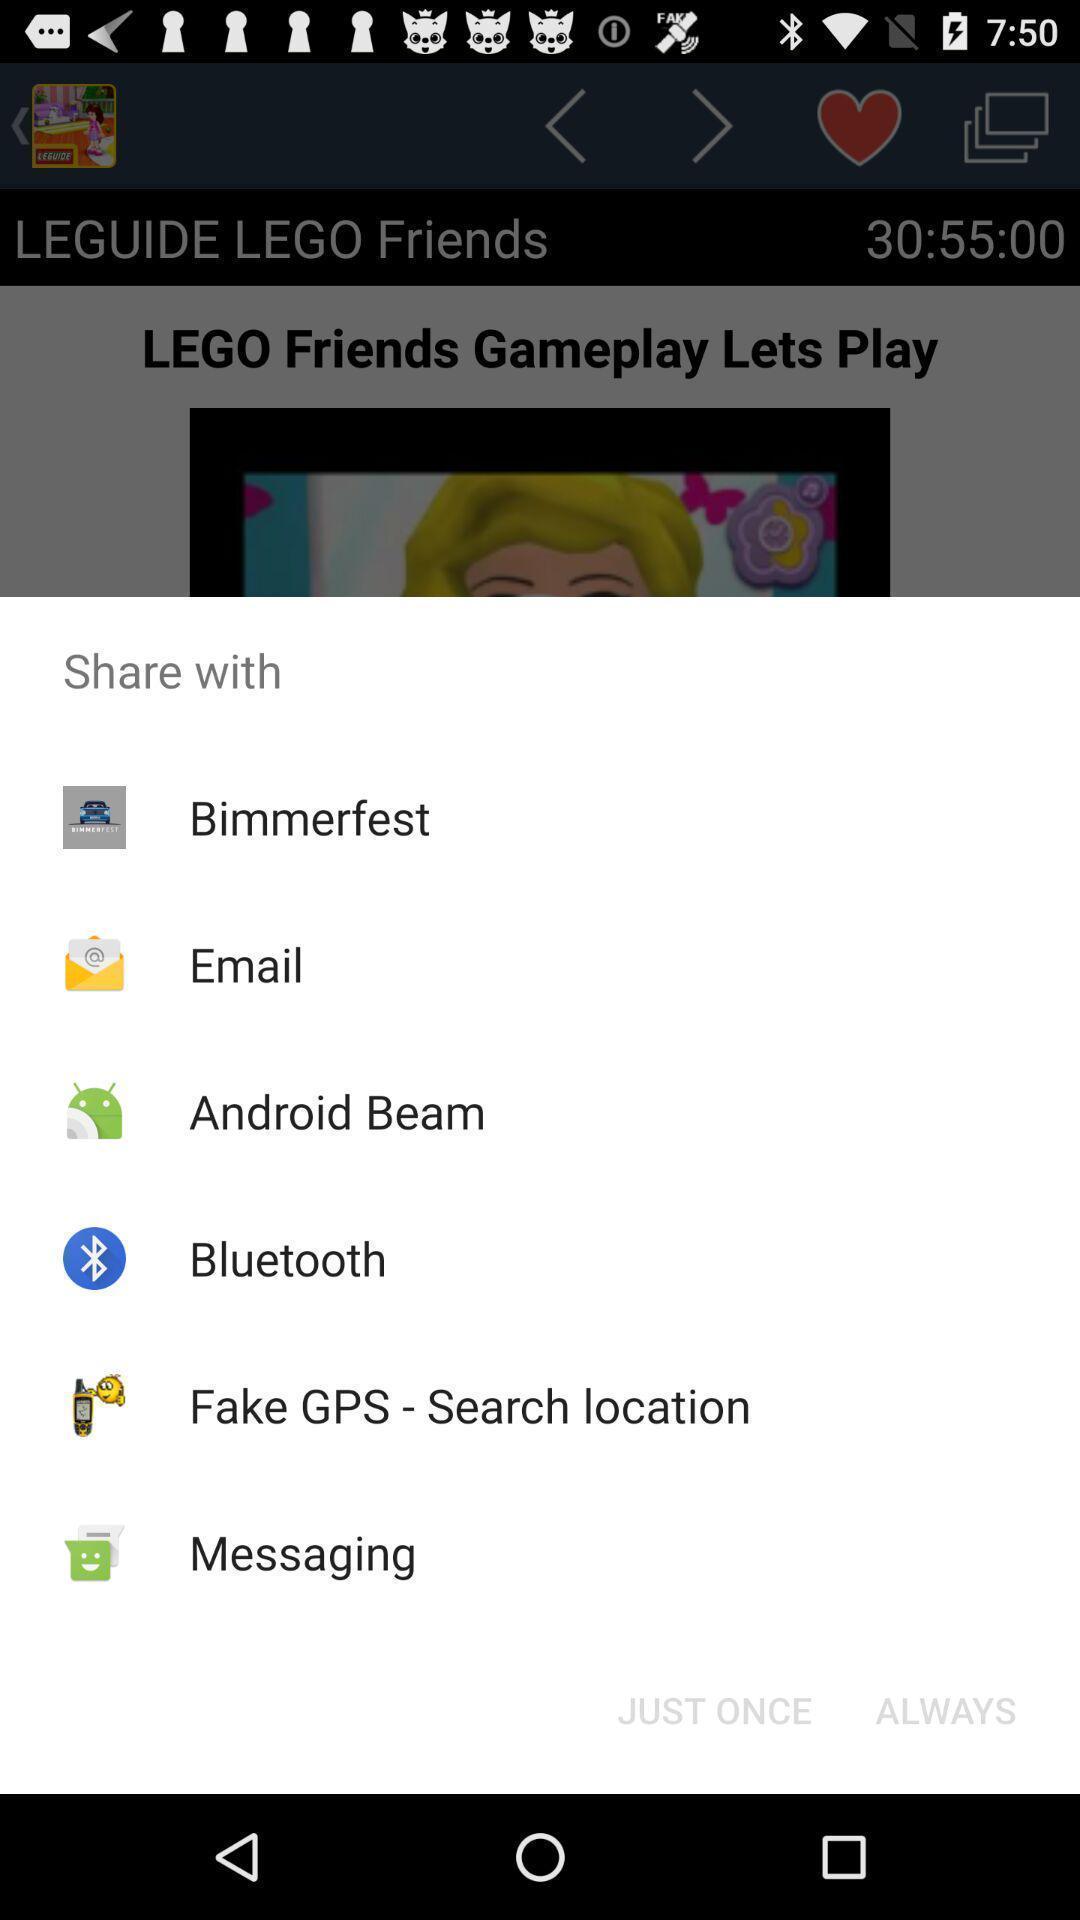Describe the content in this image. Pop-up shows an option to share with multiple applications. 